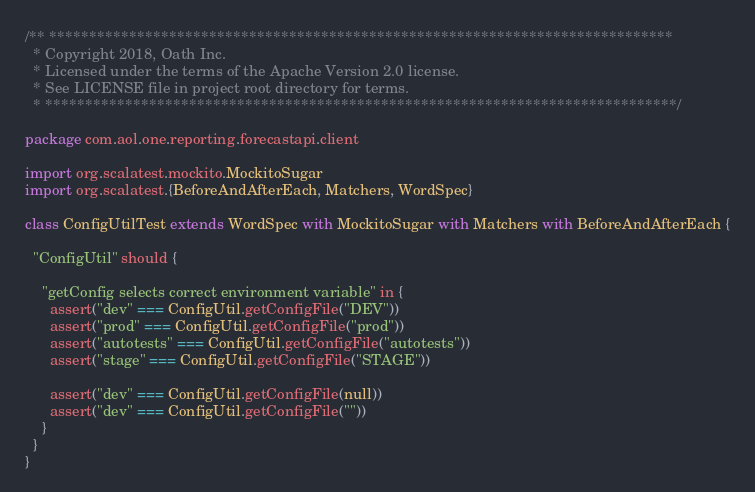<code> <loc_0><loc_0><loc_500><loc_500><_Scala_>/** ******************************************************************************
  * Copyright 2018, Oath Inc.
  * Licensed under the terms of the Apache Version 2.0 license.
  * See LICENSE file in project root directory for terms.
  * *******************************************************************************/

package com.aol.one.reporting.forecastapi.client

import org.scalatest.mockito.MockitoSugar
import org.scalatest.{BeforeAndAfterEach, Matchers, WordSpec}

class ConfigUtilTest extends WordSpec with MockitoSugar with Matchers with BeforeAndAfterEach {

  "ConfigUtil" should {

    "getConfig selects correct environment variable" in {
      assert("dev" === ConfigUtil.getConfigFile("DEV"))
      assert("prod" === ConfigUtil.getConfigFile("prod"))
      assert("autotests" === ConfigUtil.getConfigFile("autotests"))
      assert("stage" === ConfigUtil.getConfigFile("STAGE"))

      assert("dev" === ConfigUtil.getConfigFile(null))
      assert("dev" === ConfigUtil.getConfigFile(""))
    }
  }
}
</code> 